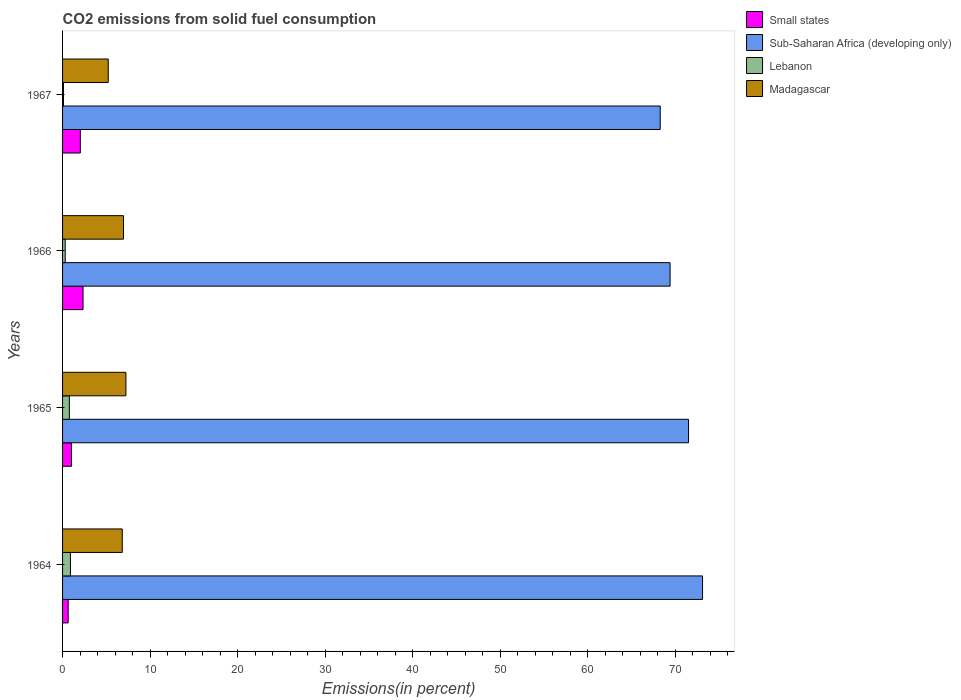How many different coloured bars are there?
Keep it short and to the point. 4. How many groups of bars are there?
Your answer should be compact. 4. Are the number of bars per tick equal to the number of legend labels?
Provide a short and direct response. Yes. Are the number of bars on each tick of the Y-axis equal?
Provide a short and direct response. Yes. What is the label of the 3rd group of bars from the top?
Your response must be concise. 1965. In how many cases, is the number of bars for a given year not equal to the number of legend labels?
Ensure brevity in your answer.  0. What is the total CO2 emitted in Sub-Saharan Africa (developing only) in 1966?
Offer a terse response. 69.39. Across all years, what is the maximum total CO2 emitted in Lebanon?
Ensure brevity in your answer.  0.9. Across all years, what is the minimum total CO2 emitted in Madagascar?
Make the answer very short. 5.22. In which year was the total CO2 emitted in Small states maximum?
Offer a very short reply. 1966. In which year was the total CO2 emitted in Small states minimum?
Your response must be concise. 1964. What is the total total CO2 emitted in Small states in the graph?
Make the answer very short. 6.03. What is the difference between the total CO2 emitted in Lebanon in 1964 and that in 1967?
Your response must be concise. 0.8. What is the difference between the total CO2 emitted in Sub-Saharan Africa (developing only) in 1966 and the total CO2 emitted in Small states in 1964?
Give a very brief answer. 68.75. What is the average total CO2 emitted in Madagascar per year?
Ensure brevity in your answer.  6.56. In the year 1965, what is the difference between the total CO2 emitted in Madagascar and total CO2 emitted in Small states?
Offer a very short reply. 6.22. In how many years, is the total CO2 emitted in Madagascar greater than 42 %?
Provide a succinct answer. 0. What is the ratio of the total CO2 emitted in Madagascar in 1966 to that in 1967?
Provide a succinct answer. 1.33. Is the total CO2 emitted in Madagascar in 1965 less than that in 1967?
Ensure brevity in your answer.  No. Is the difference between the total CO2 emitted in Madagascar in 1964 and 1965 greater than the difference between the total CO2 emitted in Small states in 1964 and 1965?
Provide a short and direct response. No. What is the difference between the highest and the second highest total CO2 emitted in Small states?
Give a very brief answer. 0.31. What is the difference between the highest and the lowest total CO2 emitted in Sub-Saharan Africa (developing only)?
Offer a very short reply. 4.83. In how many years, is the total CO2 emitted in Small states greater than the average total CO2 emitted in Small states taken over all years?
Provide a succinct answer. 2. Is the sum of the total CO2 emitted in Lebanon in 1965 and 1966 greater than the maximum total CO2 emitted in Sub-Saharan Africa (developing only) across all years?
Give a very brief answer. No. What does the 2nd bar from the top in 1965 represents?
Provide a short and direct response. Lebanon. What does the 3rd bar from the bottom in 1965 represents?
Ensure brevity in your answer.  Lebanon. Is it the case that in every year, the sum of the total CO2 emitted in Lebanon and total CO2 emitted in Madagascar is greater than the total CO2 emitted in Small states?
Keep it short and to the point. Yes. How many bars are there?
Give a very brief answer. 16. Are all the bars in the graph horizontal?
Provide a short and direct response. Yes. Are the values on the major ticks of X-axis written in scientific E-notation?
Keep it short and to the point. No. How are the legend labels stacked?
Offer a very short reply. Vertical. What is the title of the graph?
Your answer should be very brief. CO2 emissions from solid fuel consumption. Does "OECD members" appear as one of the legend labels in the graph?
Ensure brevity in your answer.  No. What is the label or title of the X-axis?
Your answer should be very brief. Emissions(in percent). What is the Emissions(in percent) in Small states in 1964?
Offer a terse response. 0.64. What is the Emissions(in percent) of Sub-Saharan Africa (developing only) in 1964?
Offer a terse response. 73.1. What is the Emissions(in percent) of Lebanon in 1964?
Give a very brief answer. 0.9. What is the Emissions(in percent) of Madagascar in 1964?
Your answer should be compact. 6.82. What is the Emissions(in percent) of Small states in 1965?
Offer a terse response. 1.02. What is the Emissions(in percent) of Sub-Saharan Africa (developing only) in 1965?
Provide a short and direct response. 71.5. What is the Emissions(in percent) of Lebanon in 1965?
Give a very brief answer. 0.77. What is the Emissions(in percent) of Madagascar in 1965?
Your answer should be compact. 7.24. What is the Emissions(in percent) of Small states in 1966?
Ensure brevity in your answer.  2.34. What is the Emissions(in percent) of Sub-Saharan Africa (developing only) in 1966?
Your response must be concise. 69.39. What is the Emissions(in percent) of Lebanon in 1966?
Give a very brief answer. 0.3. What is the Emissions(in percent) in Madagascar in 1966?
Ensure brevity in your answer.  6.96. What is the Emissions(in percent) in Small states in 1967?
Give a very brief answer. 2.03. What is the Emissions(in percent) of Sub-Saharan Africa (developing only) in 1967?
Your answer should be very brief. 68.27. What is the Emissions(in percent) in Lebanon in 1967?
Ensure brevity in your answer.  0.1. What is the Emissions(in percent) of Madagascar in 1967?
Keep it short and to the point. 5.22. Across all years, what is the maximum Emissions(in percent) in Small states?
Keep it short and to the point. 2.34. Across all years, what is the maximum Emissions(in percent) of Sub-Saharan Africa (developing only)?
Give a very brief answer. 73.1. Across all years, what is the maximum Emissions(in percent) in Lebanon?
Ensure brevity in your answer.  0.9. Across all years, what is the maximum Emissions(in percent) of Madagascar?
Provide a succinct answer. 7.24. Across all years, what is the minimum Emissions(in percent) of Small states?
Give a very brief answer. 0.64. Across all years, what is the minimum Emissions(in percent) in Sub-Saharan Africa (developing only)?
Provide a short and direct response. 68.27. Across all years, what is the minimum Emissions(in percent) of Lebanon?
Your response must be concise. 0.1. Across all years, what is the minimum Emissions(in percent) of Madagascar?
Provide a short and direct response. 5.22. What is the total Emissions(in percent) of Small states in the graph?
Keep it short and to the point. 6.03. What is the total Emissions(in percent) of Sub-Saharan Africa (developing only) in the graph?
Give a very brief answer. 282.27. What is the total Emissions(in percent) in Lebanon in the graph?
Your answer should be very brief. 2.08. What is the total Emissions(in percent) in Madagascar in the graph?
Provide a short and direct response. 26.23. What is the difference between the Emissions(in percent) in Small states in 1964 and that in 1965?
Keep it short and to the point. -0.38. What is the difference between the Emissions(in percent) of Sub-Saharan Africa (developing only) in 1964 and that in 1965?
Keep it short and to the point. 1.6. What is the difference between the Emissions(in percent) in Lebanon in 1964 and that in 1965?
Offer a very short reply. 0.12. What is the difference between the Emissions(in percent) of Madagascar in 1964 and that in 1965?
Your answer should be very brief. -0.42. What is the difference between the Emissions(in percent) in Small states in 1964 and that in 1966?
Your answer should be very brief. -1.7. What is the difference between the Emissions(in percent) of Sub-Saharan Africa (developing only) in 1964 and that in 1966?
Keep it short and to the point. 3.71. What is the difference between the Emissions(in percent) of Lebanon in 1964 and that in 1966?
Give a very brief answer. 0.59. What is the difference between the Emissions(in percent) in Madagascar in 1964 and that in 1966?
Your answer should be compact. -0.14. What is the difference between the Emissions(in percent) in Small states in 1964 and that in 1967?
Your answer should be compact. -1.39. What is the difference between the Emissions(in percent) of Sub-Saharan Africa (developing only) in 1964 and that in 1967?
Keep it short and to the point. 4.83. What is the difference between the Emissions(in percent) of Lebanon in 1964 and that in 1967?
Keep it short and to the point. 0.8. What is the difference between the Emissions(in percent) of Madagascar in 1964 and that in 1967?
Provide a short and direct response. 1.6. What is the difference between the Emissions(in percent) in Small states in 1965 and that in 1966?
Provide a short and direct response. -1.32. What is the difference between the Emissions(in percent) in Sub-Saharan Africa (developing only) in 1965 and that in 1966?
Make the answer very short. 2.11. What is the difference between the Emissions(in percent) of Lebanon in 1965 and that in 1966?
Ensure brevity in your answer.  0.47. What is the difference between the Emissions(in percent) in Madagascar in 1965 and that in 1966?
Make the answer very short. 0.27. What is the difference between the Emissions(in percent) in Small states in 1965 and that in 1967?
Offer a very short reply. -1.01. What is the difference between the Emissions(in percent) in Sub-Saharan Africa (developing only) in 1965 and that in 1967?
Your response must be concise. 3.24. What is the difference between the Emissions(in percent) in Lebanon in 1965 and that in 1967?
Keep it short and to the point. 0.67. What is the difference between the Emissions(in percent) of Madagascar in 1965 and that in 1967?
Give a very brief answer. 2.02. What is the difference between the Emissions(in percent) of Small states in 1966 and that in 1967?
Keep it short and to the point. 0.31. What is the difference between the Emissions(in percent) of Sub-Saharan Africa (developing only) in 1966 and that in 1967?
Your answer should be compact. 1.13. What is the difference between the Emissions(in percent) in Lebanon in 1966 and that in 1967?
Ensure brevity in your answer.  0.2. What is the difference between the Emissions(in percent) of Madagascar in 1966 and that in 1967?
Give a very brief answer. 1.74. What is the difference between the Emissions(in percent) of Small states in 1964 and the Emissions(in percent) of Sub-Saharan Africa (developing only) in 1965?
Provide a succinct answer. -70.86. What is the difference between the Emissions(in percent) of Small states in 1964 and the Emissions(in percent) of Lebanon in 1965?
Offer a very short reply. -0.13. What is the difference between the Emissions(in percent) of Small states in 1964 and the Emissions(in percent) of Madagascar in 1965?
Offer a terse response. -6.6. What is the difference between the Emissions(in percent) in Sub-Saharan Africa (developing only) in 1964 and the Emissions(in percent) in Lebanon in 1965?
Make the answer very short. 72.33. What is the difference between the Emissions(in percent) in Sub-Saharan Africa (developing only) in 1964 and the Emissions(in percent) in Madagascar in 1965?
Make the answer very short. 65.87. What is the difference between the Emissions(in percent) of Lebanon in 1964 and the Emissions(in percent) of Madagascar in 1965?
Your answer should be very brief. -6.34. What is the difference between the Emissions(in percent) in Small states in 1964 and the Emissions(in percent) in Sub-Saharan Africa (developing only) in 1966?
Give a very brief answer. -68.75. What is the difference between the Emissions(in percent) of Small states in 1964 and the Emissions(in percent) of Lebanon in 1966?
Provide a short and direct response. 0.34. What is the difference between the Emissions(in percent) of Small states in 1964 and the Emissions(in percent) of Madagascar in 1966?
Provide a short and direct response. -6.32. What is the difference between the Emissions(in percent) in Sub-Saharan Africa (developing only) in 1964 and the Emissions(in percent) in Lebanon in 1966?
Provide a short and direct response. 72.8. What is the difference between the Emissions(in percent) of Sub-Saharan Africa (developing only) in 1964 and the Emissions(in percent) of Madagascar in 1966?
Provide a succinct answer. 66.14. What is the difference between the Emissions(in percent) in Lebanon in 1964 and the Emissions(in percent) in Madagascar in 1966?
Give a very brief answer. -6.06. What is the difference between the Emissions(in percent) of Small states in 1964 and the Emissions(in percent) of Sub-Saharan Africa (developing only) in 1967?
Provide a succinct answer. -67.63. What is the difference between the Emissions(in percent) in Small states in 1964 and the Emissions(in percent) in Lebanon in 1967?
Keep it short and to the point. 0.54. What is the difference between the Emissions(in percent) of Small states in 1964 and the Emissions(in percent) of Madagascar in 1967?
Your answer should be compact. -4.58. What is the difference between the Emissions(in percent) of Sub-Saharan Africa (developing only) in 1964 and the Emissions(in percent) of Lebanon in 1967?
Make the answer very short. 73. What is the difference between the Emissions(in percent) in Sub-Saharan Africa (developing only) in 1964 and the Emissions(in percent) in Madagascar in 1967?
Provide a short and direct response. 67.88. What is the difference between the Emissions(in percent) of Lebanon in 1964 and the Emissions(in percent) of Madagascar in 1967?
Offer a very short reply. -4.32. What is the difference between the Emissions(in percent) in Small states in 1965 and the Emissions(in percent) in Sub-Saharan Africa (developing only) in 1966?
Your response must be concise. -68.38. What is the difference between the Emissions(in percent) of Small states in 1965 and the Emissions(in percent) of Lebanon in 1966?
Give a very brief answer. 0.71. What is the difference between the Emissions(in percent) of Small states in 1965 and the Emissions(in percent) of Madagascar in 1966?
Give a very brief answer. -5.95. What is the difference between the Emissions(in percent) in Sub-Saharan Africa (developing only) in 1965 and the Emissions(in percent) in Lebanon in 1966?
Provide a succinct answer. 71.2. What is the difference between the Emissions(in percent) in Sub-Saharan Africa (developing only) in 1965 and the Emissions(in percent) in Madagascar in 1966?
Provide a short and direct response. 64.54. What is the difference between the Emissions(in percent) in Lebanon in 1965 and the Emissions(in percent) in Madagascar in 1966?
Your answer should be very brief. -6.19. What is the difference between the Emissions(in percent) in Small states in 1965 and the Emissions(in percent) in Sub-Saharan Africa (developing only) in 1967?
Your response must be concise. -67.25. What is the difference between the Emissions(in percent) in Small states in 1965 and the Emissions(in percent) in Madagascar in 1967?
Give a very brief answer. -4.2. What is the difference between the Emissions(in percent) in Sub-Saharan Africa (developing only) in 1965 and the Emissions(in percent) in Lebanon in 1967?
Offer a very short reply. 71.4. What is the difference between the Emissions(in percent) of Sub-Saharan Africa (developing only) in 1965 and the Emissions(in percent) of Madagascar in 1967?
Provide a succinct answer. 66.28. What is the difference between the Emissions(in percent) in Lebanon in 1965 and the Emissions(in percent) in Madagascar in 1967?
Ensure brevity in your answer.  -4.44. What is the difference between the Emissions(in percent) in Small states in 1966 and the Emissions(in percent) in Sub-Saharan Africa (developing only) in 1967?
Offer a terse response. -65.93. What is the difference between the Emissions(in percent) in Small states in 1966 and the Emissions(in percent) in Lebanon in 1967?
Your answer should be very brief. 2.24. What is the difference between the Emissions(in percent) in Small states in 1966 and the Emissions(in percent) in Madagascar in 1967?
Provide a short and direct response. -2.88. What is the difference between the Emissions(in percent) in Sub-Saharan Africa (developing only) in 1966 and the Emissions(in percent) in Lebanon in 1967?
Ensure brevity in your answer.  69.29. What is the difference between the Emissions(in percent) of Sub-Saharan Africa (developing only) in 1966 and the Emissions(in percent) of Madagascar in 1967?
Your answer should be very brief. 64.18. What is the difference between the Emissions(in percent) in Lebanon in 1966 and the Emissions(in percent) in Madagascar in 1967?
Give a very brief answer. -4.91. What is the average Emissions(in percent) of Small states per year?
Make the answer very short. 1.51. What is the average Emissions(in percent) of Sub-Saharan Africa (developing only) per year?
Make the answer very short. 70.57. What is the average Emissions(in percent) of Lebanon per year?
Offer a very short reply. 0.52. What is the average Emissions(in percent) of Madagascar per year?
Make the answer very short. 6.56. In the year 1964, what is the difference between the Emissions(in percent) in Small states and Emissions(in percent) in Sub-Saharan Africa (developing only)?
Give a very brief answer. -72.46. In the year 1964, what is the difference between the Emissions(in percent) in Small states and Emissions(in percent) in Lebanon?
Your answer should be very brief. -0.26. In the year 1964, what is the difference between the Emissions(in percent) of Small states and Emissions(in percent) of Madagascar?
Offer a very short reply. -6.18. In the year 1964, what is the difference between the Emissions(in percent) of Sub-Saharan Africa (developing only) and Emissions(in percent) of Lebanon?
Offer a very short reply. 72.2. In the year 1964, what is the difference between the Emissions(in percent) in Sub-Saharan Africa (developing only) and Emissions(in percent) in Madagascar?
Your answer should be very brief. 66.28. In the year 1964, what is the difference between the Emissions(in percent) of Lebanon and Emissions(in percent) of Madagascar?
Offer a very short reply. -5.92. In the year 1965, what is the difference between the Emissions(in percent) in Small states and Emissions(in percent) in Sub-Saharan Africa (developing only)?
Your response must be concise. -70.49. In the year 1965, what is the difference between the Emissions(in percent) of Small states and Emissions(in percent) of Lebanon?
Keep it short and to the point. 0.24. In the year 1965, what is the difference between the Emissions(in percent) of Small states and Emissions(in percent) of Madagascar?
Give a very brief answer. -6.22. In the year 1965, what is the difference between the Emissions(in percent) of Sub-Saharan Africa (developing only) and Emissions(in percent) of Lebanon?
Provide a short and direct response. 70.73. In the year 1965, what is the difference between the Emissions(in percent) in Sub-Saharan Africa (developing only) and Emissions(in percent) in Madagascar?
Provide a succinct answer. 64.27. In the year 1965, what is the difference between the Emissions(in percent) of Lebanon and Emissions(in percent) of Madagascar?
Provide a succinct answer. -6.46. In the year 1966, what is the difference between the Emissions(in percent) of Small states and Emissions(in percent) of Sub-Saharan Africa (developing only)?
Provide a short and direct response. -67.05. In the year 1966, what is the difference between the Emissions(in percent) of Small states and Emissions(in percent) of Lebanon?
Make the answer very short. 2.04. In the year 1966, what is the difference between the Emissions(in percent) of Small states and Emissions(in percent) of Madagascar?
Offer a very short reply. -4.62. In the year 1966, what is the difference between the Emissions(in percent) in Sub-Saharan Africa (developing only) and Emissions(in percent) in Lebanon?
Your response must be concise. 69.09. In the year 1966, what is the difference between the Emissions(in percent) of Sub-Saharan Africa (developing only) and Emissions(in percent) of Madagascar?
Ensure brevity in your answer.  62.43. In the year 1966, what is the difference between the Emissions(in percent) in Lebanon and Emissions(in percent) in Madagascar?
Offer a terse response. -6.66. In the year 1967, what is the difference between the Emissions(in percent) in Small states and Emissions(in percent) in Sub-Saharan Africa (developing only)?
Your answer should be very brief. -66.24. In the year 1967, what is the difference between the Emissions(in percent) of Small states and Emissions(in percent) of Lebanon?
Give a very brief answer. 1.93. In the year 1967, what is the difference between the Emissions(in percent) of Small states and Emissions(in percent) of Madagascar?
Ensure brevity in your answer.  -3.19. In the year 1967, what is the difference between the Emissions(in percent) of Sub-Saharan Africa (developing only) and Emissions(in percent) of Lebanon?
Provide a short and direct response. 68.16. In the year 1967, what is the difference between the Emissions(in percent) in Sub-Saharan Africa (developing only) and Emissions(in percent) in Madagascar?
Your answer should be very brief. 63.05. In the year 1967, what is the difference between the Emissions(in percent) of Lebanon and Emissions(in percent) of Madagascar?
Give a very brief answer. -5.11. What is the ratio of the Emissions(in percent) in Small states in 1964 to that in 1965?
Offer a very short reply. 0.63. What is the ratio of the Emissions(in percent) in Sub-Saharan Africa (developing only) in 1964 to that in 1965?
Your answer should be very brief. 1.02. What is the ratio of the Emissions(in percent) of Lebanon in 1964 to that in 1965?
Your answer should be compact. 1.16. What is the ratio of the Emissions(in percent) of Madagascar in 1964 to that in 1965?
Your answer should be very brief. 0.94. What is the ratio of the Emissions(in percent) in Small states in 1964 to that in 1966?
Give a very brief answer. 0.27. What is the ratio of the Emissions(in percent) in Sub-Saharan Africa (developing only) in 1964 to that in 1966?
Provide a short and direct response. 1.05. What is the ratio of the Emissions(in percent) in Lebanon in 1964 to that in 1966?
Your response must be concise. 2.96. What is the ratio of the Emissions(in percent) in Madagascar in 1964 to that in 1966?
Your response must be concise. 0.98. What is the ratio of the Emissions(in percent) in Small states in 1964 to that in 1967?
Your answer should be compact. 0.32. What is the ratio of the Emissions(in percent) of Sub-Saharan Africa (developing only) in 1964 to that in 1967?
Ensure brevity in your answer.  1.07. What is the ratio of the Emissions(in percent) of Lebanon in 1964 to that in 1967?
Provide a succinct answer. 8.75. What is the ratio of the Emissions(in percent) in Madagascar in 1964 to that in 1967?
Your answer should be very brief. 1.31. What is the ratio of the Emissions(in percent) in Small states in 1965 to that in 1966?
Provide a short and direct response. 0.43. What is the ratio of the Emissions(in percent) of Sub-Saharan Africa (developing only) in 1965 to that in 1966?
Offer a very short reply. 1.03. What is the ratio of the Emissions(in percent) in Lebanon in 1965 to that in 1966?
Keep it short and to the point. 2.55. What is the ratio of the Emissions(in percent) of Madagascar in 1965 to that in 1966?
Give a very brief answer. 1.04. What is the ratio of the Emissions(in percent) in Small states in 1965 to that in 1967?
Give a very brief answer. 0.5. What is the ratio of the Emissions(in percent) in Sub-Saharan Africa (developing only) in 1965 to that in 1967?
Offer a terse response. 1.05. What is the ratio of the Emissions(in percent) of Lebanon in 1965 to that in 1967?
Offer a terse response. 7.53. What is the ratio of the Emissions(in percent) in Madagascar in 1965 to that in 1967?
Offer a very short reply. 1.39. What is the ratio of the Emissions(in percent) of Small states in 1966 to that in 1967?
Give a very brief answer. 1.15. What is the ratio of the Emissions(in percent) of Sub-Saharan Africa (developing only) in 1966 to that in 1967?
Provide a succinct answer. 1.02. What is the ratio of the Emissions(in percent) in Lebanon in 1966 to that in 1967?
Your answer should be compact. 2.95. What is the ratio of the Emissions(in percent) of Madagascar in 1966 to that in 1967?
Offer a terse response. 1.33. What is the difference between the highest and the second highest Emissions(in percent) in Small states?
Keep it short and to the point. 0.31. What is the difference between the highest and the second highest Emissions(in percent) of Sub-Saharan Africa (developing only)?
Offer a very short reply. 1.6. What is the difference between the highest and the second highest Emissions(in percent) of Lebanon?
Provide a short and direct response. 0.12. What is the difference between the highest and the second highest Emissions(in percent) in Madagascar?
Offer a very short reply. 0.27. What is the difference between the highest and the lowest Emissions(in percent) of Small states?
Offer a very short reply. 1.7. What is the difference between the highest and the lowest Emissions(in percent) in Sub-Saharan Africa (developing only)?
Provide a succinct answer. 4.83. What is the difference between the highest and the lowest Emissions(in percent) in Lebanon?
Your answer should be very brief. 0.8. What is the difference between the highest and the lowest Emissions(in percent) in Madagascar?
Give a very brief answer. 2.02. 